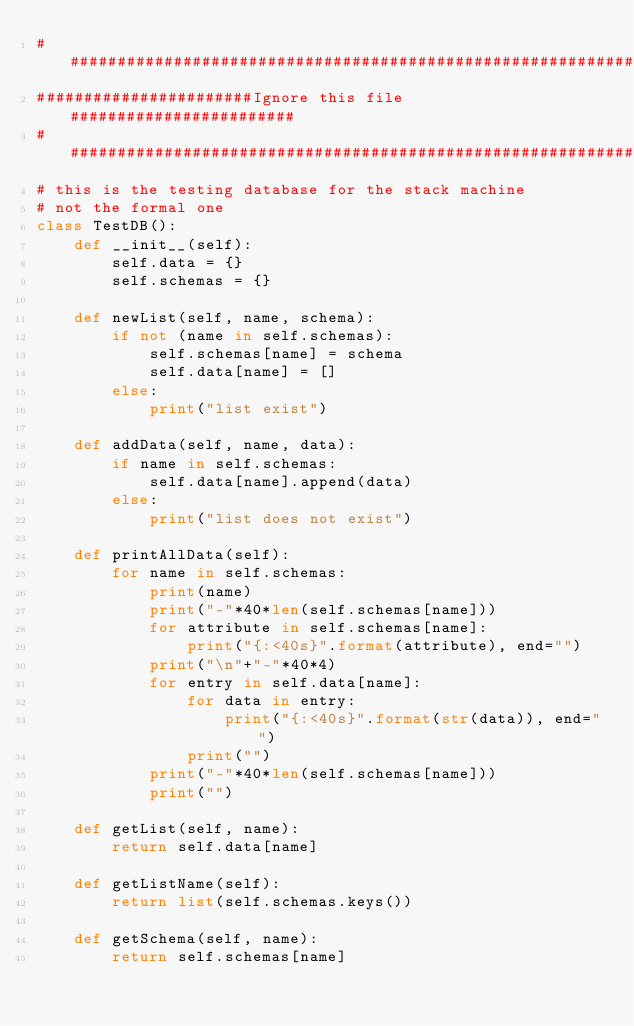<code> <loc_0><loc_0><loc_500><loc_500><_Python_>###############################################################
#######################Ignore this file########################
###############################################################
# this is the testing database for the stack machine
# not the formal one
class TestDB():
    def __init__(self):
        self.data = {}
        self.schemas = {}

    def newList(self, name, schema):
        if not (name in self.schemas):
            self.schemas[name] = schema
            self.data[name] = []
        else:
            print("list exist")

    def addData(self, name, data):
        if name in self.schemas:
            self.data[name].append(data)
        else:
            print("list does not exist")

    def printAllData(self):
        for name in self.schemas:
            print(name)
            print("-"*40*len(self.schemas[name]))
            for attribute in self.schemas[name]:
                print("{:<40s}".format(attribute), end="")
            print("\n"+"-"*40*4)
            for entry in self.data[name]:
                for data in entry:
                    print("{:<40s}".format(str(data)), end="")
                print("")
            print("-"*40*len(self.schemas[name]))
            print("")

    def getList(self, name):
        return self.data[name]

    def getListName(self):
        return list(self.schemas.keys())

    def getSchema(self, name):
        return self.schemas[name]</code> 